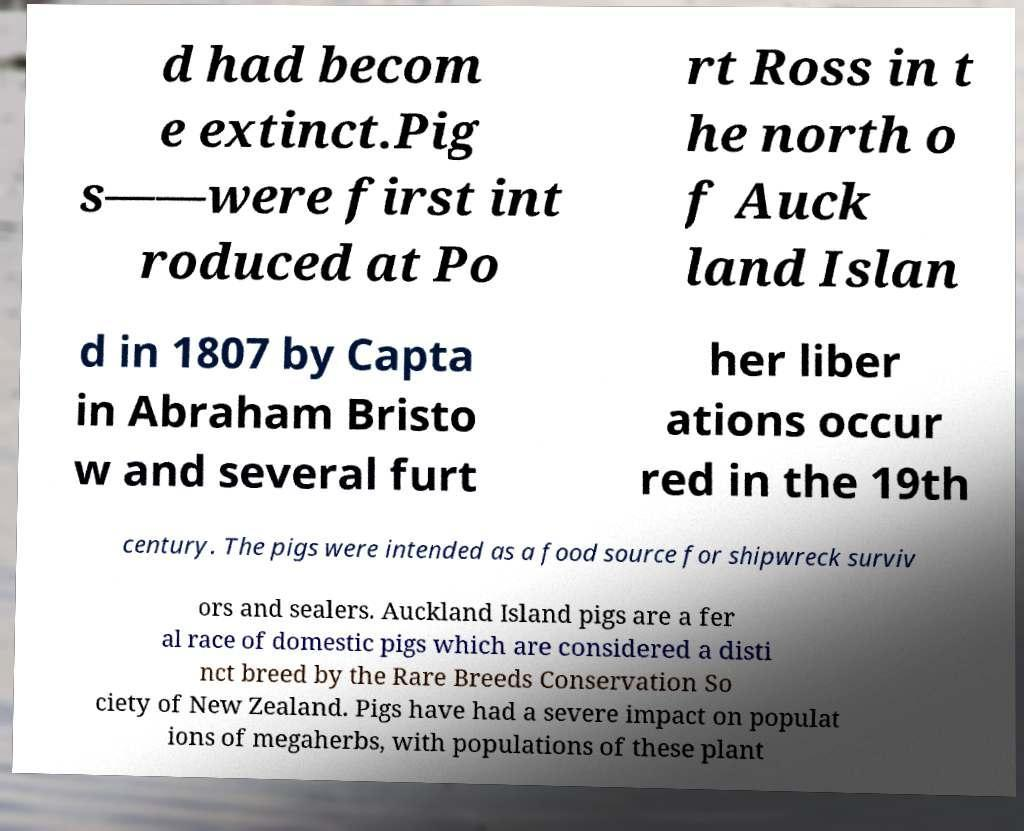Please identify and transcribe the text found in this image. d had becom e extinct.Pig s——were first int roduced at Po rt Ross in t he north o f Auck land Islan d in 1807 by Capta in Abraham Bristo w and several furt her liber ations occur red in the 19th century. The pigs were intended as a food source for shipwreck surviv ors and sealers. Auckland Island pigs are a fer al race of domestic pigs which are considered a disti nct breed by the Rare Breeds Conservation So ciety of New Zealand. Pigs have had a severe impact on populat ions of megaherbs, with populations of these plant 